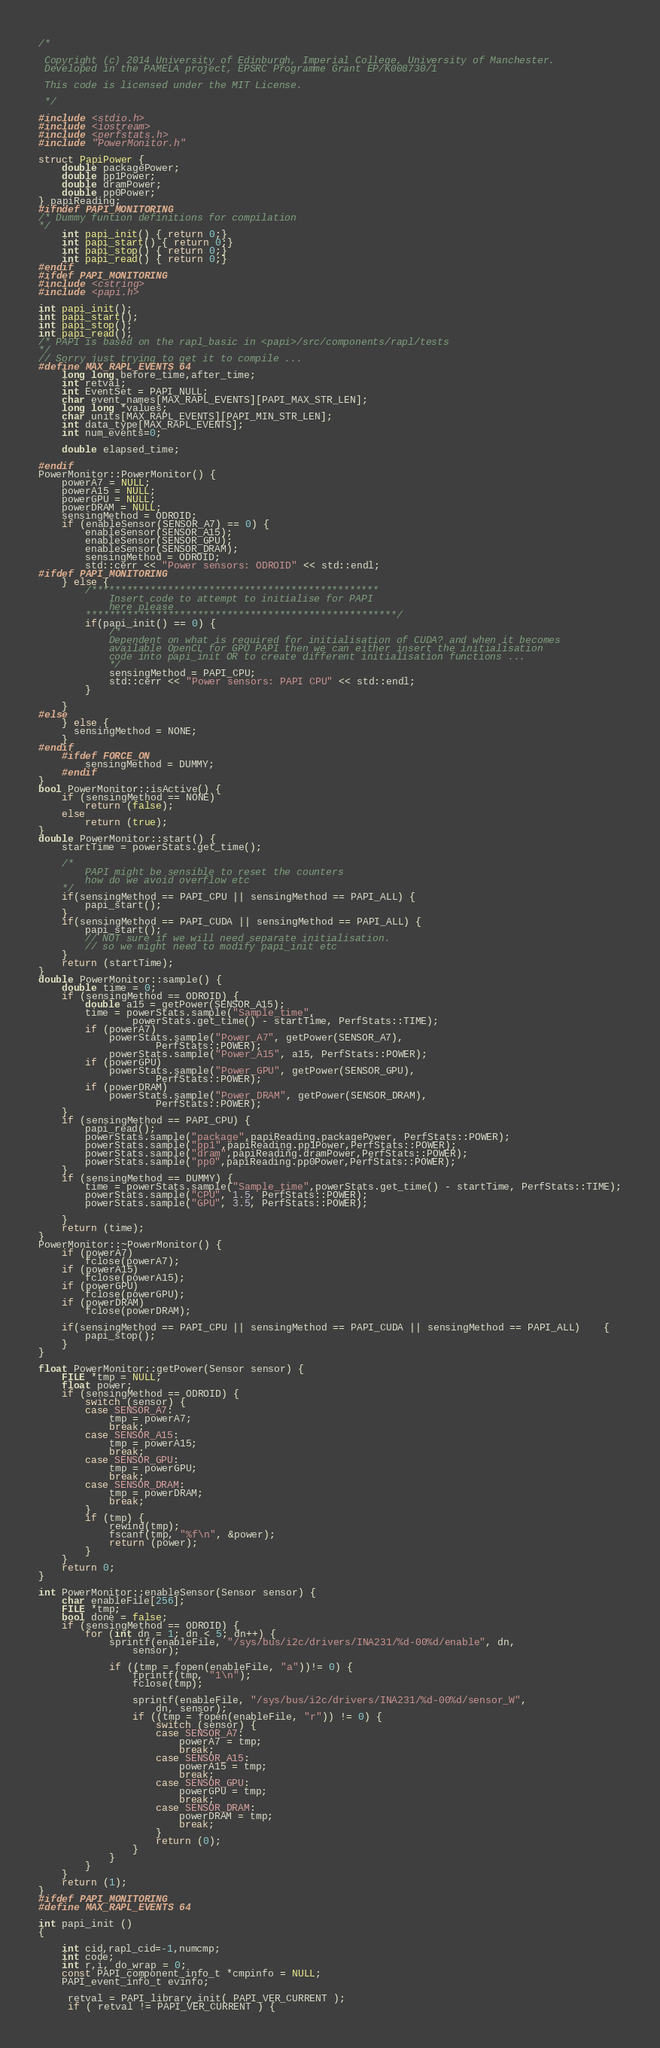<code> <loc_0><loc_0><loc_500><loc_500><_C++_>/*

 Copyright (c) 2014 University of Edinburgh, Imperial College, University of Manchester.
 Developed in the PAMELA project, EPSRC Programme Grant EP/K008730/1

 This code is licensed under the MIT License.

 */

#include <stdio.h>
#include <iostream>
#include <perfstats.h>
#include "PowerMonitor.h"

struct PapiPower {
	double packagePower;
	double pp1Power;
	double dramPower;
	double pp0Power;
} papiReading;
#ifndef PAPI_MONITORING
/* Dummy funtion definitions for compilation
*/
	int papi_init() { return 0;}
	int papi_start() { return 0;}
	int papi_stop() { return 0;}
	int papi_read() { return 0;}
#endif
#ifdef PAPI_MONITORING
#include <cstring>
#include <papi.h>

int papi_init();
int papi_start();
int papi_stop();
int papi_read();
/* PAPI is based on the rapl_basic in <papi>/src/components/rapl/tests
*/
// Sorry just trying to get it to compile ...
#define MAX_RAPL_EVENTS 64
    long long before_time,after_time;
    int retval;
    int EventSet = PAPI_NULL;
    char event_names[MAX_RAPL_EVENTS][PAPI_MAX_STR_LEN];
    long long *values;
    char units[MAX_RAPL_EVENTS][PAPI_MIN_STR_LEN];
    int data_type[MAX_RAPL_EVENTS];
    int num_events=0;

    double elapsed_time;

#endif
PowerMonitor::PowerMonitor() {
	powerA7 = NULL;
	powerA15 = NULL;
	powerGPU = NULL;
	powerDRAM = NULL;
	sensingMethod = ODROID;
	if (enableSensor(SENSOR_A7) == 0) {
		enableSensor(SENSOR_A15);
		enableSensor(SENSOR_GPU);
		enableSensor(SENSOR_DRAM);
		sensingMethod = ODROID;
		std::cerr << "Power sensors: ODROID" << std::endl;
#ifdef PAPI_MONITORING
	} else {
		/*************************************************
			Insert code to attempt to initialise for PAPI
			here please
		*****************************************************/
		if(papi_init() == 0) {
			/*
			Dependent on what is required for initialisation of CUDA? and when it becomes
			available OpenCL for GPU PAPI then we can either insert the initialisation
			code into papi_init OR to create different initialisation functions ...
			*/
			sensingMethod = PAPI_CPU;
			std::cerr << "Power sensors: PAPI CPU" << std::endl;
		}

	}
#else
	} else {
	  sensingMethod = NONE;
	}
#endif
	#ifdef FORCE_ON
		sensingMethod = DUMMY;
	#endif
}
bool PowerMonitor::isActive() {
	if (sensingMethod == NONE)
		return (false);
	else
		return (true);
}
double PowerMonitor::start() {
	startTime = powerStats.get_time();

	/*
		PAPI might be sensible to reset the counters
		how do we avoid overflow etc
	*/
	if(sensingMethod == PAPI_CPU || sensingMethod == PAPI_ALL) {
		papi_start();
	} 
	if(sensingMethod == PAPI_CUDA || sensingMethod == PAPI_ALL) {
		papi_start();
		// NOT sure if we will need separate initialisation.
		// so we might need to modify papi_init etc
	}
	return (startTime);
}
double PowerMonitor::sample() {
	double time = 0;
	if (sensingMethod == ODROID) {
		double a15 = getPower(SENSOR_A15);
		time = powerStats.sample("Sample_time",
				powerStats.get_time() - startTime, PerfStats::TIME);
		if (powerA7)
			powerStats.sample("Power_A7", getPower(SENSOR_A7),
					PerfStats::POWER);
			powerStats.sample("Power_A15", a15, PerfStats::POWER);
		if (powerGPU)
			powerStats.sample("Power_GPU", getPower(SENSOR_GPU),
					PerfStats::POWER);
		if (powerDRAM)
			powerStats.sample("Power_DRAM", getPower(SENSOR_DRAM),
					PerfStats::POWER);
	}
	if (sensingMethod == PAPI_CPU) {
		papi_read();
		powerStats.sample("package",papiReading.packagePower, PerfStats::POWER);
		powerStats.sample("pp1",papiReading.pp1Power,PerfStats::POWER);
		powerStats.sample("dram",papiReading.dramPower,PerfStats::POWER);
		powerStats.sample("pp0",papiReading.pp0Power,PerfStats::POWER);
	}
	if (sensingMethod == DUMMY) {		
		time = powerStats.sample("Sample_time",powerStats.get_time() - startTime, PerfStats::TIME);
		powerStats.sample("CPU", 1.5, PerfStats::POWER);
		powerStats.sample("GPU", 3.5, PerfStats::POWER);
					
	}
	return (time);
}
PowerMonitor::~PowerMonitor() {
	if (powerA7)
		fclose(powerA7);
	if (powerA15)
		fclose(powerA15);
	if (powerGPU)
		fclose(powerGPU);
	if (powerDRAM)
		fclose(powerDRAM);

	if(sensingMethod == PAPI_CPU || sensingMethod == PAPI_CUDA || sensingMethod == PAPI_ALL)	{
		papi_stop();
	}
}

float PowerMonitor::getPower(Sensor sensor) {
	FILE *tmp = NULL;
	float power;
	if (sensingMethod == ODROID) {
		switch (sensor) {
		case SENSOR_A7:
			tmp = powerA7;
			break;
		case SENSOR_A15:
			tmp = powerA15;
			break;
		case SENSOR_GPU:
			tmp = powerGPU;
			break;
		case SENSOR_DRAM:
			tmp = powerDRAM;
			break;
		}
		if (tmp) {
			rewind(tmp);
			fscanf(tmp, "%f\n", &power);
			return (power);
		}
	}
	return 0;
}

int PowerMonitor::enableSensor(Sensor sensor) {
	char enableFile[256];
	FILE *tmp;
	bool done = false;
	if (sensingMethod == ODROID) {
		for (int dn = 1; dn < 5; dn++) {
			sprintf(enableFile, "/sys/bus/i2c/drivers/INA231/%d-00%d/enable", dn,
				sensor);

			if ((tmp = fopen(enableFile, "a"))!= 0) {
				fprintf(tmp, "1\n");
				fclose(tmp);

				sprintf(enableFile, "/sys/bus/i2c/drivers/INA231/%d-00%d/sensor_W",
					dn, sensor);
				if ((tmp = fopen(enableFile, "r")) != 0) {
					switch (sensor) {
					case SENSOR_A7:
						powerA7 = tmp;
						break;
					case SENSOR_A15:
						powerA15 = tmp;
						break;
					case SENSOR_GPU:
						powerGPU = tmp;
						break;
					case SENSOR_DRAM:
						powerDRAM = tmp;
						break;
					}
					return (0);
				}
			}
	  	}
	} 
	return (1);
}
#ifdef PAPI_MONITORING
#define MAX_RAPL_EVENTS 64

int papi_init ()
{

    int cid,rapl_cid=-1,numcmp;
    int code;
    int r,i, do_wrap = 0;
    const PAPI_component_info_t *cmpinfo = NULL;
    PAPI_event_info_t evinfo;

     retval = PAPI_library_init( PAPI_VER_CURRENT );
     if ( retval != PAPI_VER_CURRENT ) {</code> 